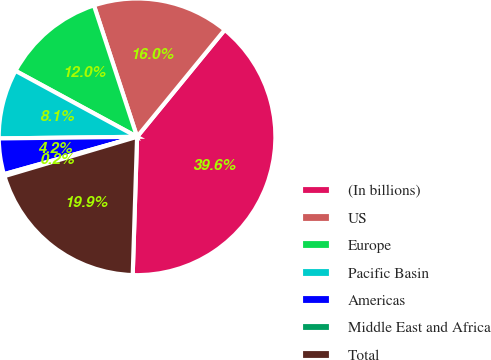Convert chart. <chart><loc_0><loc_0><loc_500><loc_500><pie_chart><fcel>(In billions)<fcel>US<fcel>Europe<fcel>Pacific Basin<fcel>Americas<fcel>Middle East and Africa<fcel>Total<nl><fcel>39.58%<fcel>15.97%<fcel>12.04%<fcel>8.1%<fcel>4.17%<fcel>0.23%<fcel>19.91%<nl></chart> 